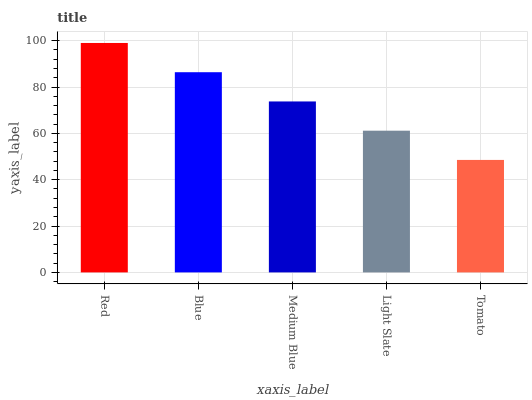Is Blue the minimum?
Answer yes or no. No. Is Blue the maximum?
Answer yes or no. No. Is Red greater than Blue?
Answer yes or no. Yes. Is Blue less than Red?
Answer yes or no. Yes. Is Blue greater than Red?
Answer yes or no. No. Is Red less than Blue?
Answer yes or no. No. Is Medium Blue the high median?
Answer yes or no. Yes. Is Medium Blue the low median?
Answer yes or no. Yes. Is Light Slate the high median?
Answer yes or no. No. Is Red the low median?
Answer yes or no. No. 